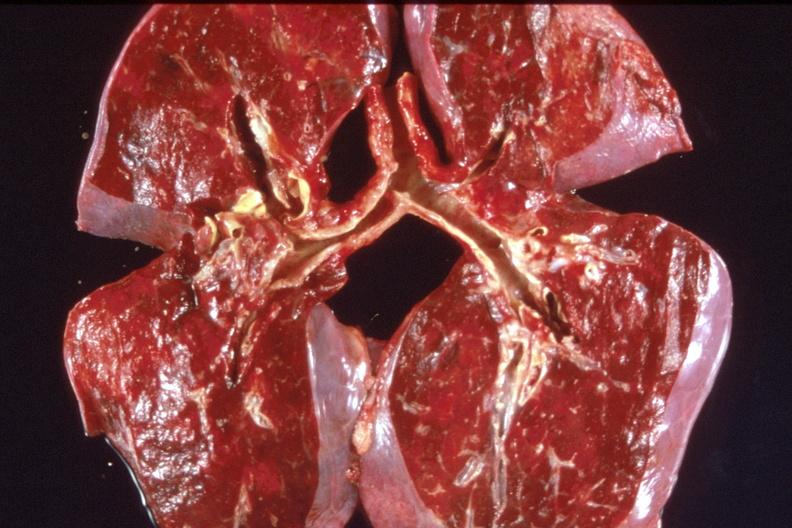s respiratory present?
Answer the question using a single word or phrase. Yes 